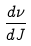Convert formula to latex. <formula><loc_0><loc_0><loc_500><loc_500>\frac { d \nu } { d J }</formula> 